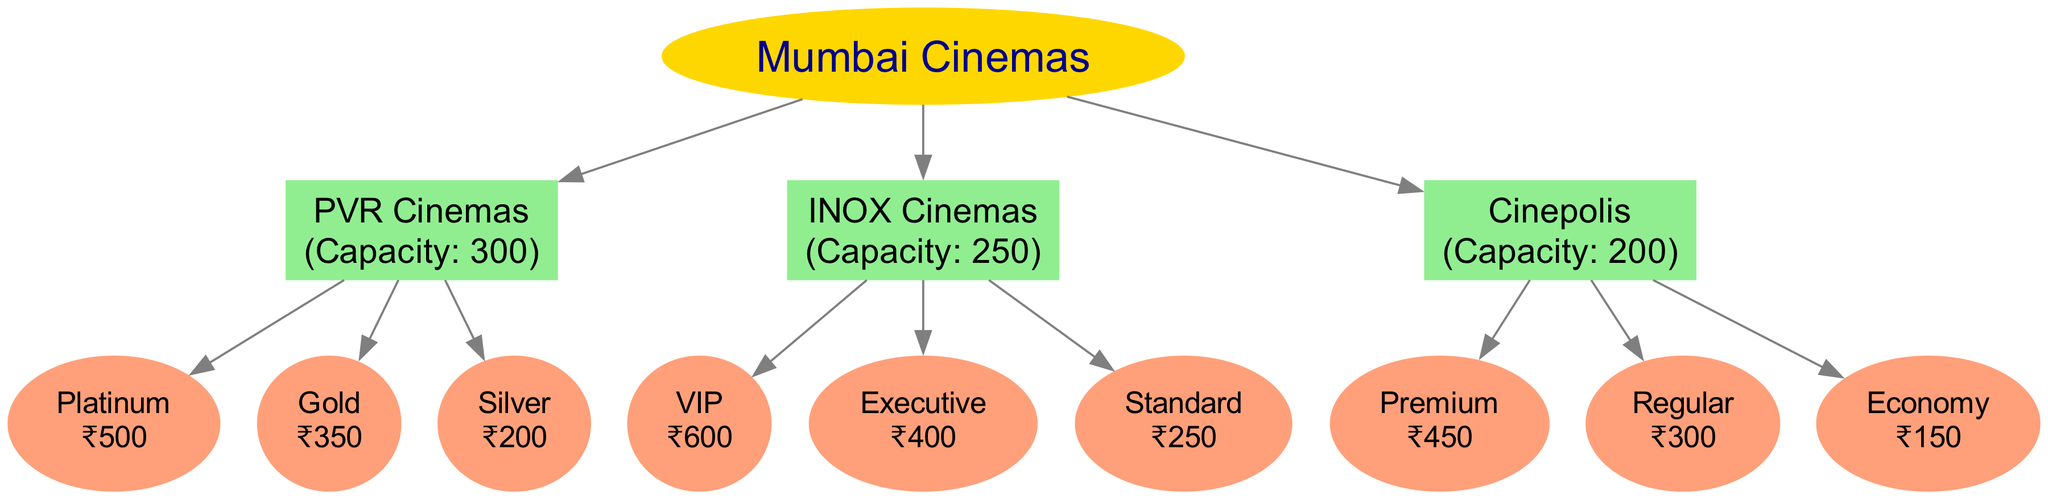What is the seating capacity of PVR Cinemas? According to the diagram, PVR Cinemas has a seating capacity of 300, which is directly stated in the node for PVR Cinemas.
Answer: 300 How many ticket categories are offered by INOX Cinemas? The INOX Cinemas node lists three ticket categories: VIP, Executive, and Standard, so the total is counted from here.
Answer: 3 What is the price of the Silver ticket category at PVR Cinemas? The Silver ticket category under PVR Cinemas is specifically priced at ₹200, as shown in its respective node.
Answer: ₹200 Which cinema hall offers the most expensive ticket category? INOX Cinemas offers a VIP ticket category priced at ₹600, which is higher than the ticket prices of any other cinema halls shown in the diagram.
Answer: INOX Cinemas What is the total number of edges connecting to ticket categories in the diagram? There are three cinema halls, each connecting to three different ticket categories, leading to a total of 9 edges connecting to these categories (3 categories x 3 halls).
Answer: 9 Which ticket category has the lowest price in Cinepolis? The Economy ticket category at Cinepolis is priced at ₹150, which is the lowest among the three categories listed for Cinepolis.
Answer: ₹150 What is the name of the category with the highest price at PVR Cinemas? The Platinum category has the highest price of ₹500, which is mentioned under the ticket categories for PVR Cinemas.
Answer: Platinum Which cinema hall has the lowest seating capacity? Cinepolis has the lowest seating capacity of 200 among the listed cinema halls, as seen from the details in its specific node.
Answer: Cinepolis What is the total seating capacity of all three cinema halls combined? The total seating capacity is calculated by adding the capacities of all three halls: 300 (PVR) + 250 (INOX) + 200 (Cinepolis) = 750.
Answer: 750 